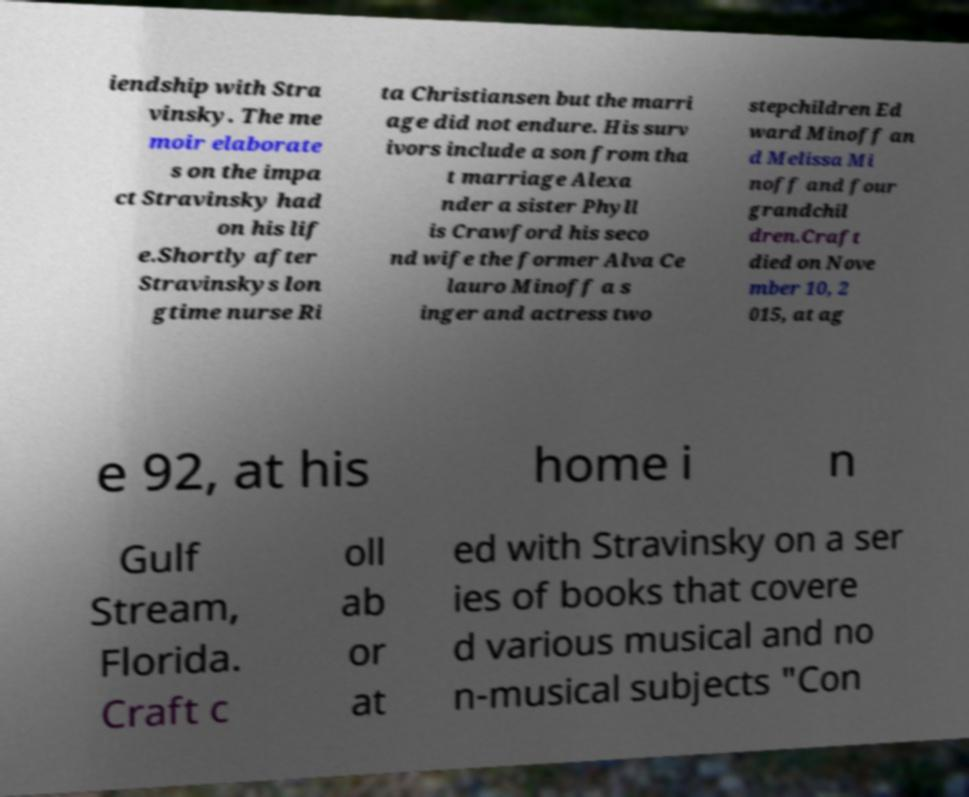Could you extract and type out the text from this image? iendship with Stra vinsky. The me moir elaborate s on the impa ct Stravinsky had on his lif e.Shortly after Stravinskys lon gtime nurse Ri ta Christiansen but the marri age did not endure. His surv ivors include a son from tha t marriage Alexa nder a sister Phyll is Crawford his seco nd wife the former Alva Ce lauro Minoff a s inger and actress two stepchildren Ed ward Minoff an d Melissa Mi noff and four grandchil dren.Craft died on Nove mber 10, 2 015, at ag e 92, at his home i n Gulf Stream, Florida. Craft c oll ab or at ed with Stravinsky on a ser ies of books that covere d various musical and no n-musical subjects "Con 